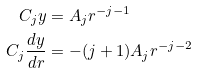<formula> <loc_0><loc_0><loc_500><loc_500>C _ { j } y & = A _ { j } r ^ { - j - 1 } \\ C _ { j } \frac { d y } { d r } & = - ( j + 1 ) A _ { j } r ^ { - j - 2 }</formula> 